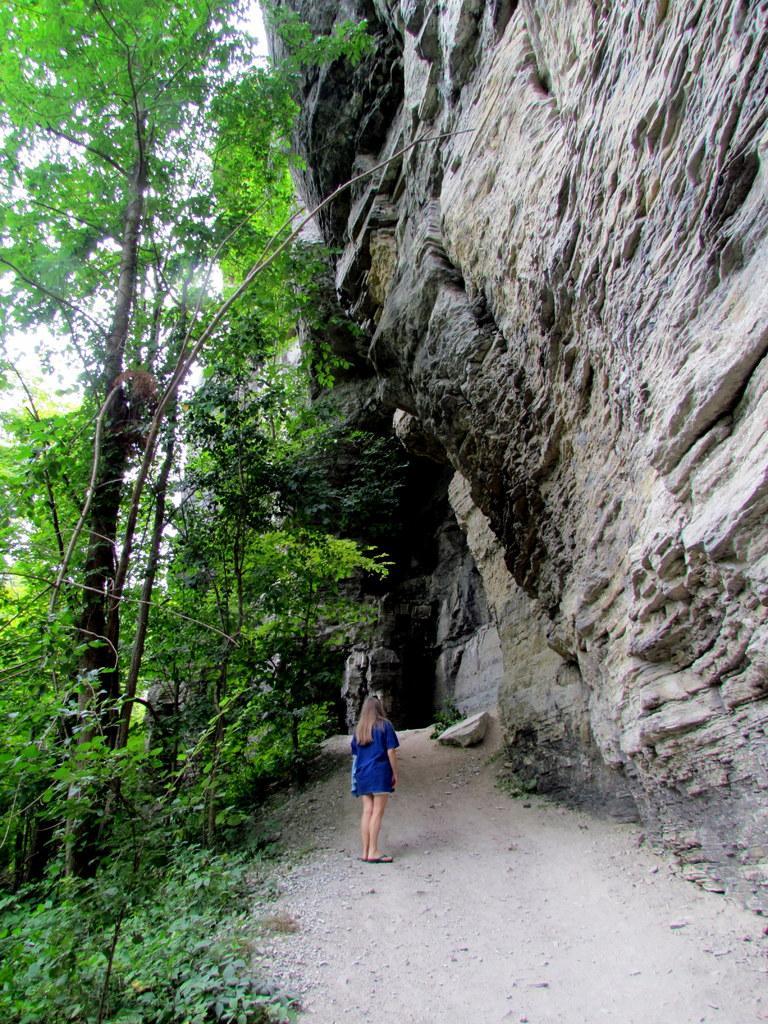Could you give a brief overview of what you see in this image? In this image I can see the person standing and the person is wearing blue color dress. In the background I can see the rock, few trees in green color and the sky is in white color. 